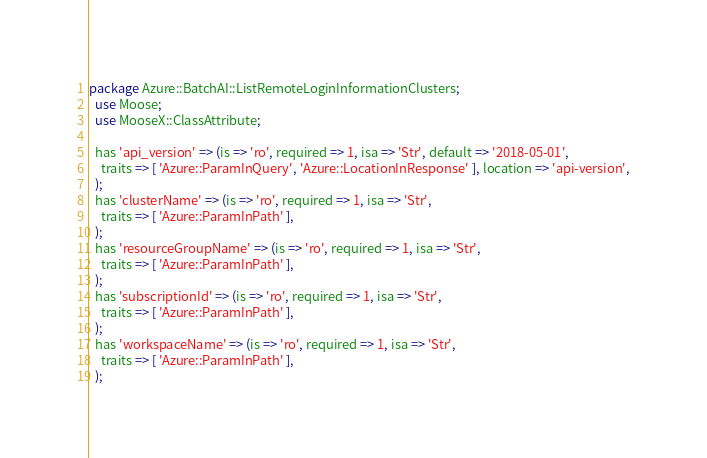<code> <loc_0><loc_0><loc_500><loc_500><_Perl_>package Azure::BatchAI::ListRemoteLoginInformationClusters;
  use Moose;
  use MooseX::ClassAttribute;

  has 'api_version' => (is => 'ro', required => 1, isa => 'Str', default => '2018-05-01',
    traits => [ 'Azure::ParamInQuery', 'Azure::LocationInResponse' ], location => 'api-version',
  );
  has 'clusterName' => (is => 'ro', required => 1, isa => 'Str',
    traits => [ 'Azure::ParamInPath' ],
  );
  has 'resourceGroupName' => (is => 'ro', required => 1, isa => 'Str',
    traits => [ 'Azure::ParamInPath' ],
  );
  has 'subscriptionId' => (is => 'ro', required => 1, isa => 'Str',
    traits => [ 'Azure::ParamInPath' ],
  );
  has 'workspaceName' => (is => 'ro', required => 1, isa => 'Str',
    traits => [ 'Azure::ParamInPath' ],
  );
</code> 